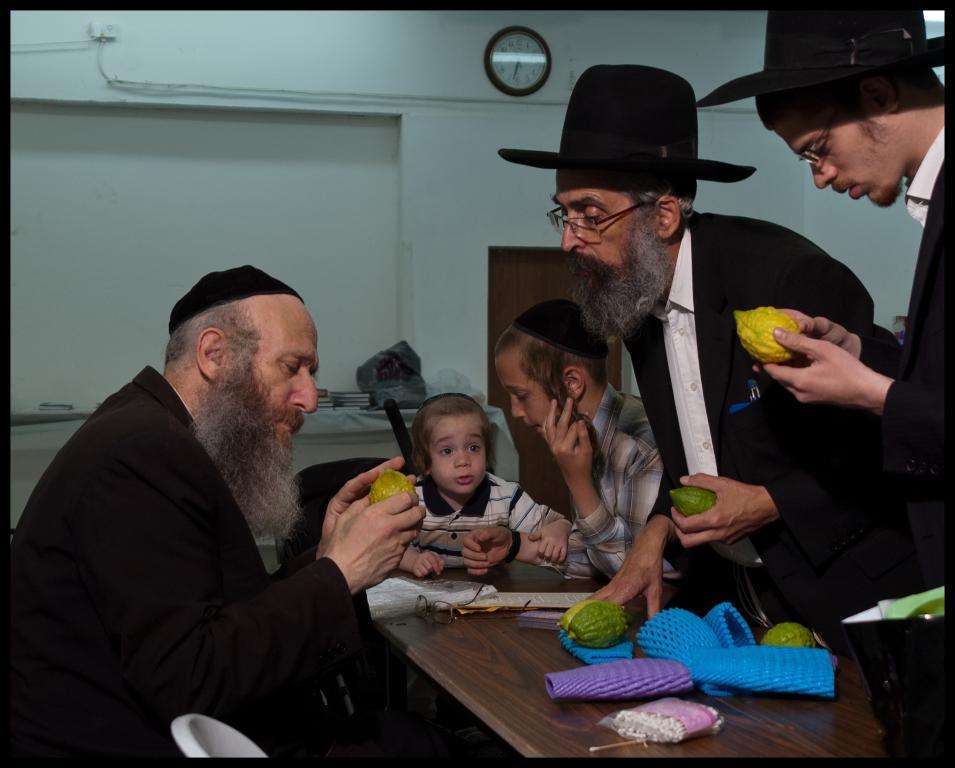Describe this image in one or two sentences. In this image I can see some people and they are holding some fruits, and some fruits on the table and in the background we can see some books, wall and a watch. 